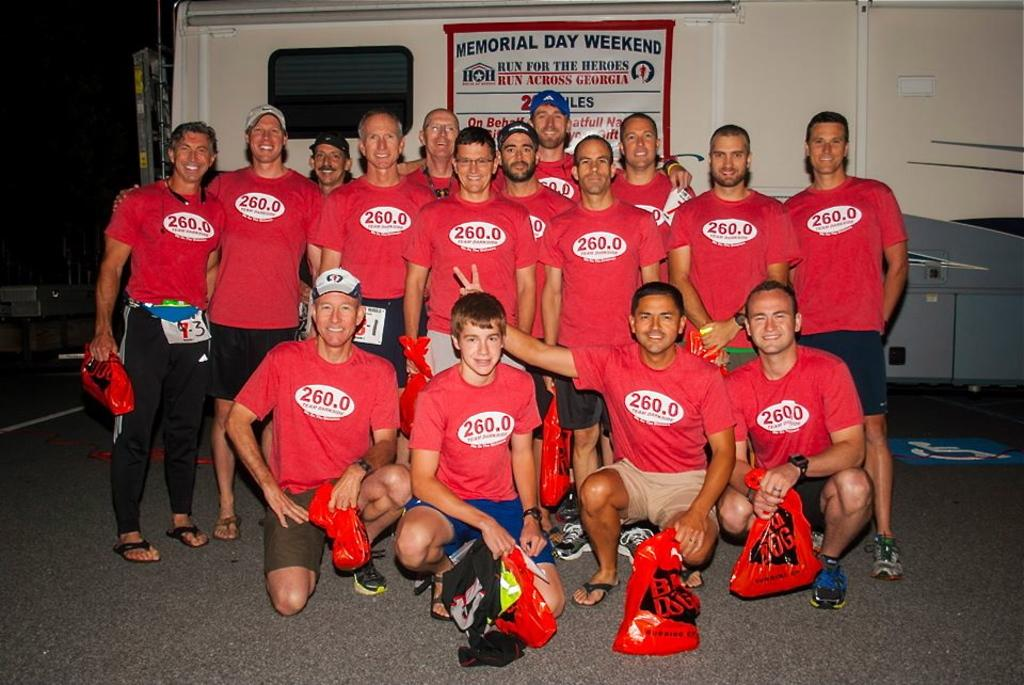<image>
Describe the image concisely. A large group of men all wearing the same top with 260.0 on them pose for a photo below a sign saying run for the heroes. 